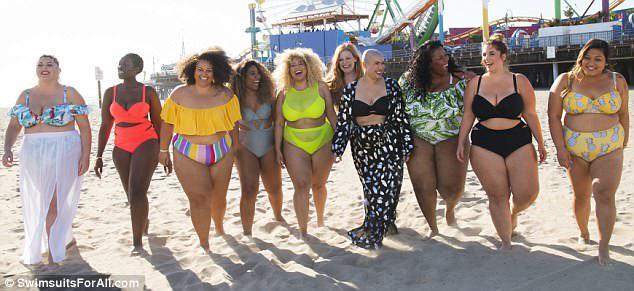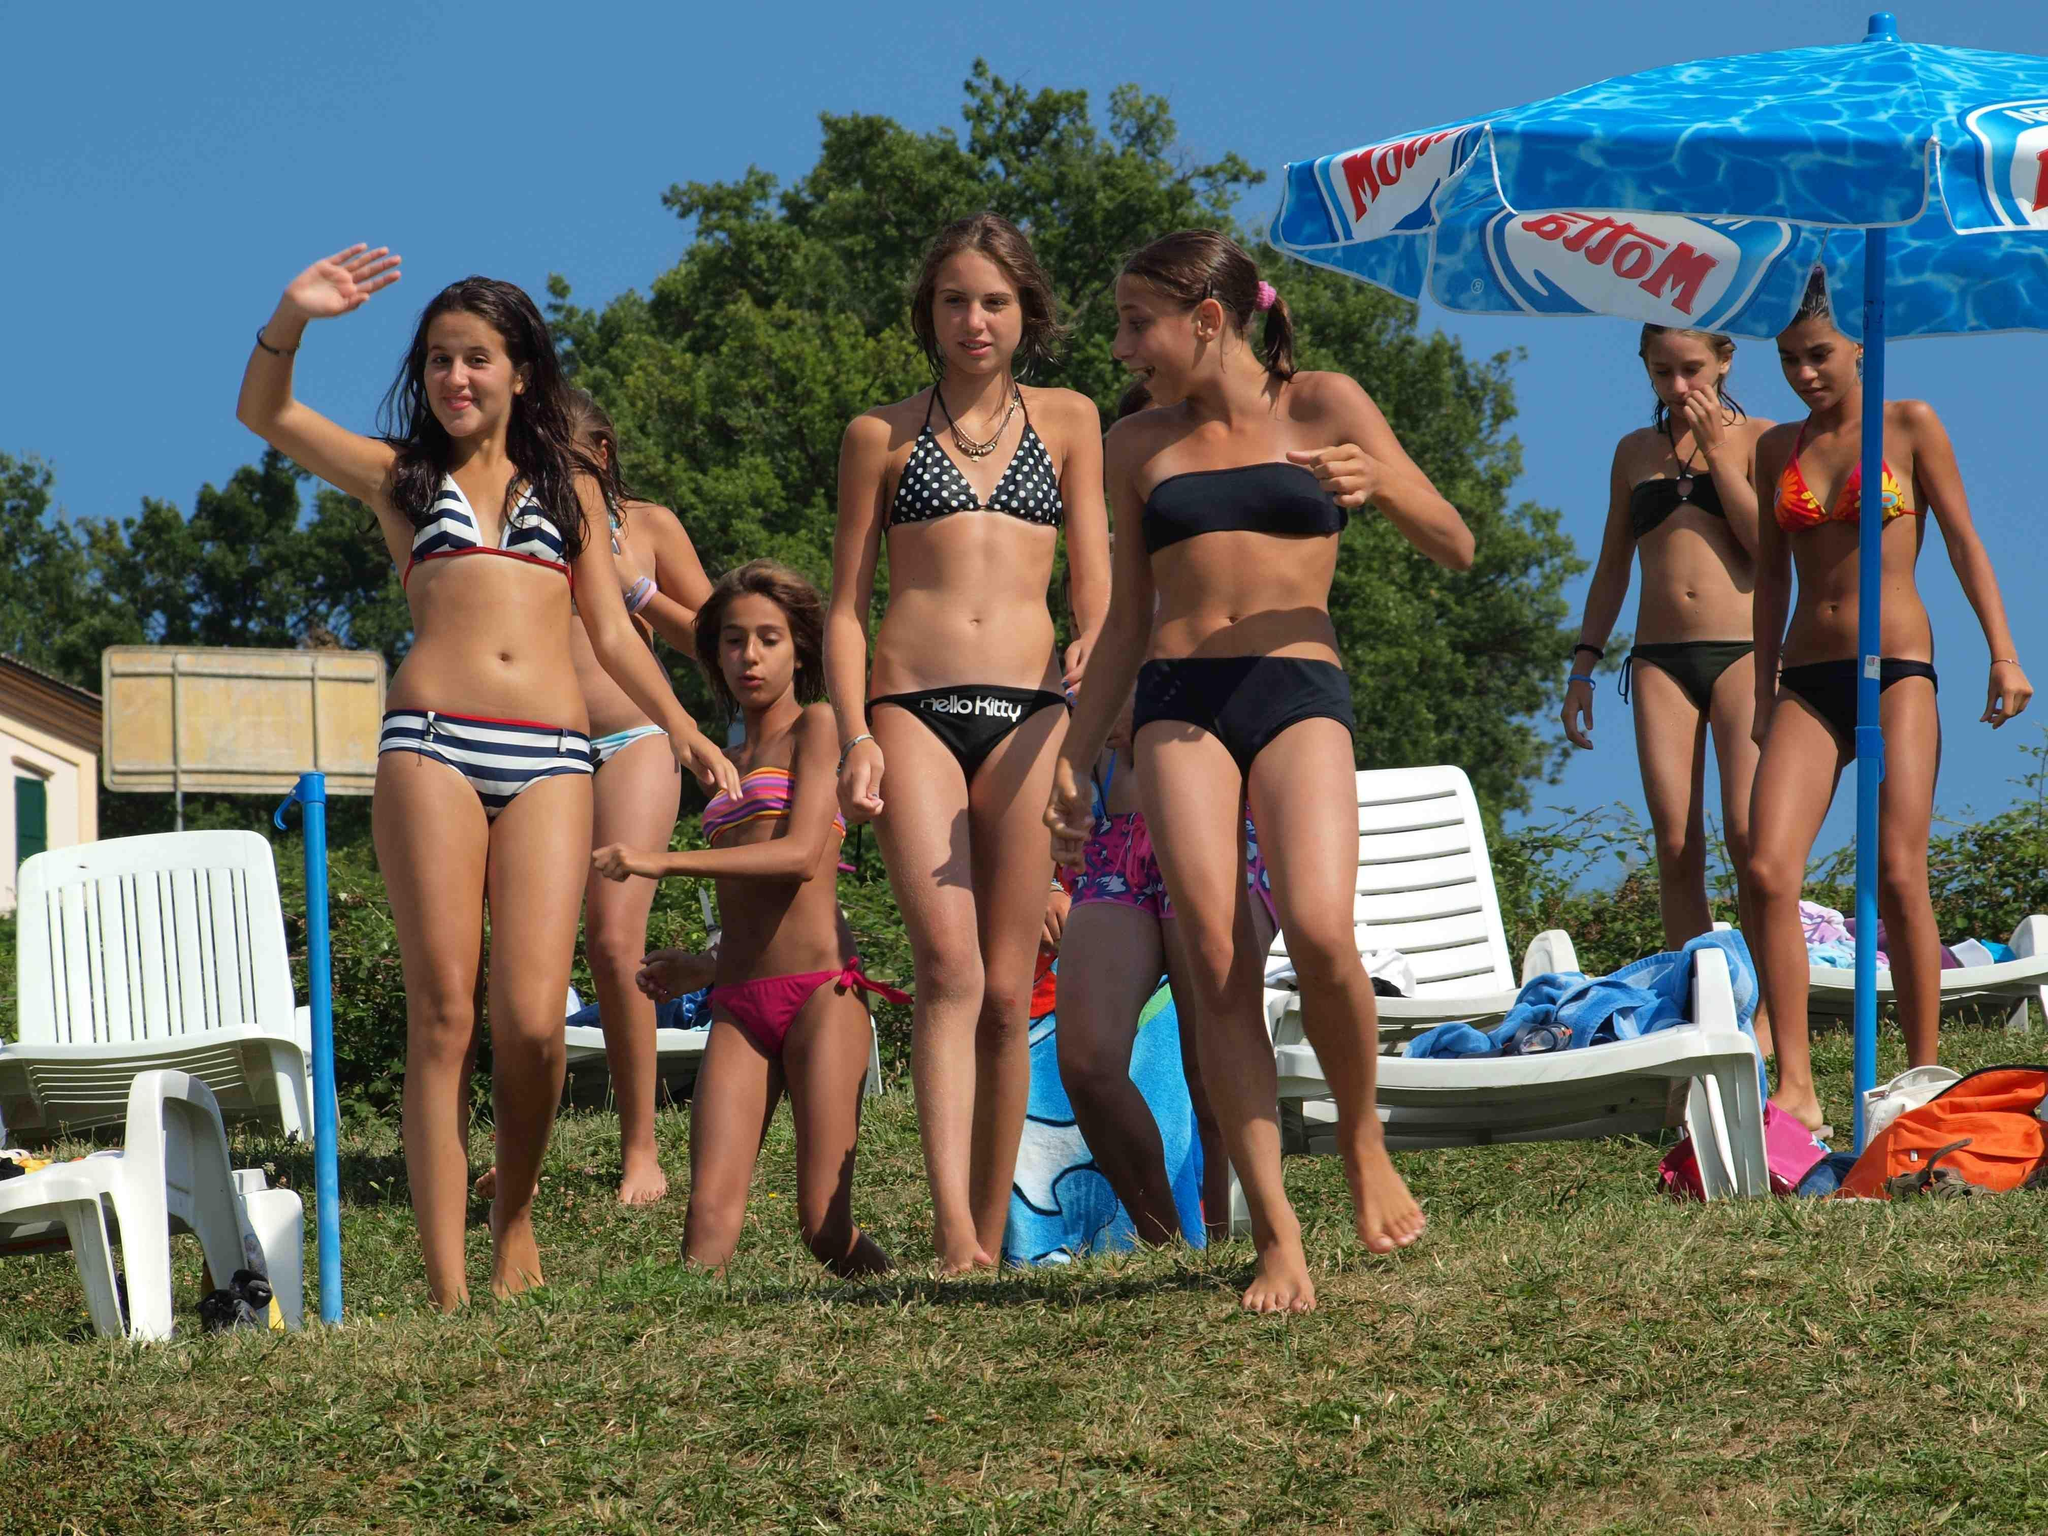The first image is the image on the left, the second image is the image on the right. For the images displayed, is the sentence "All bikini models are standing up and have their bodies facing the front." factually correct? Answer yes or no. Yes. The first image is the image on the left, the second image is the image on the right. For the images shown, is this caption "One of the images is focused on three girls wearing bikinis." true? Answer yes or no. No. 